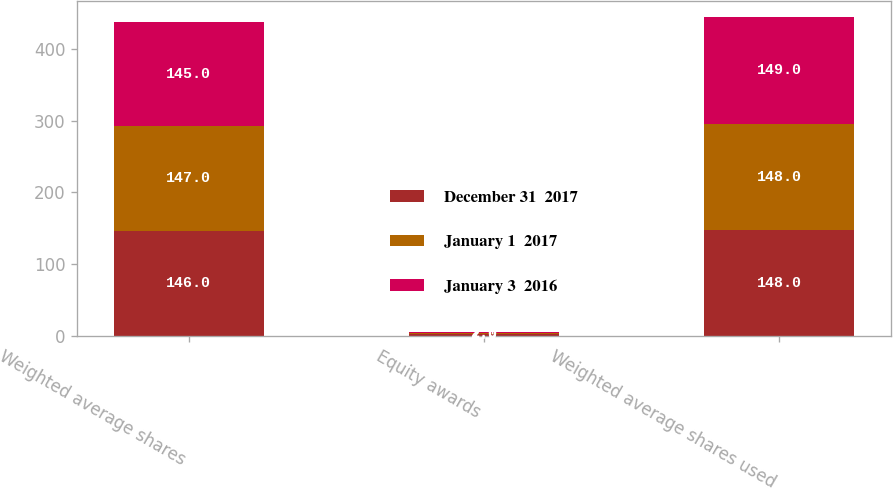Convert chart to OTSL. <chart><loc_0><loc_0><loc_500><loc_500><stacked_bar_chart><ecel><fcel>Weighted average shares<fcel>Equity awards<fcel>Weighted average shares used<nl><fcel>December 31  2017<fcel>146<fcel>2<fcel>148<nl><fcel>January 1  2017<fcel>147<fcel>1<fcel>148<nl><fcel>January 3  2016<fcel>145<fcel>2<fcel>149<nl></chart> 